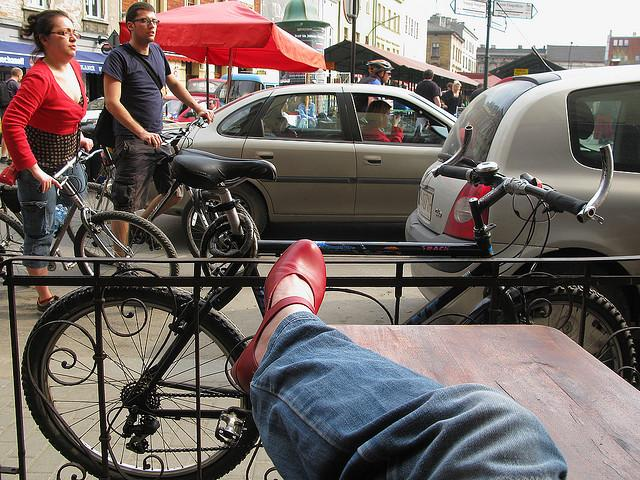How is doing what the photo taker is doing with their leg considered? rude 